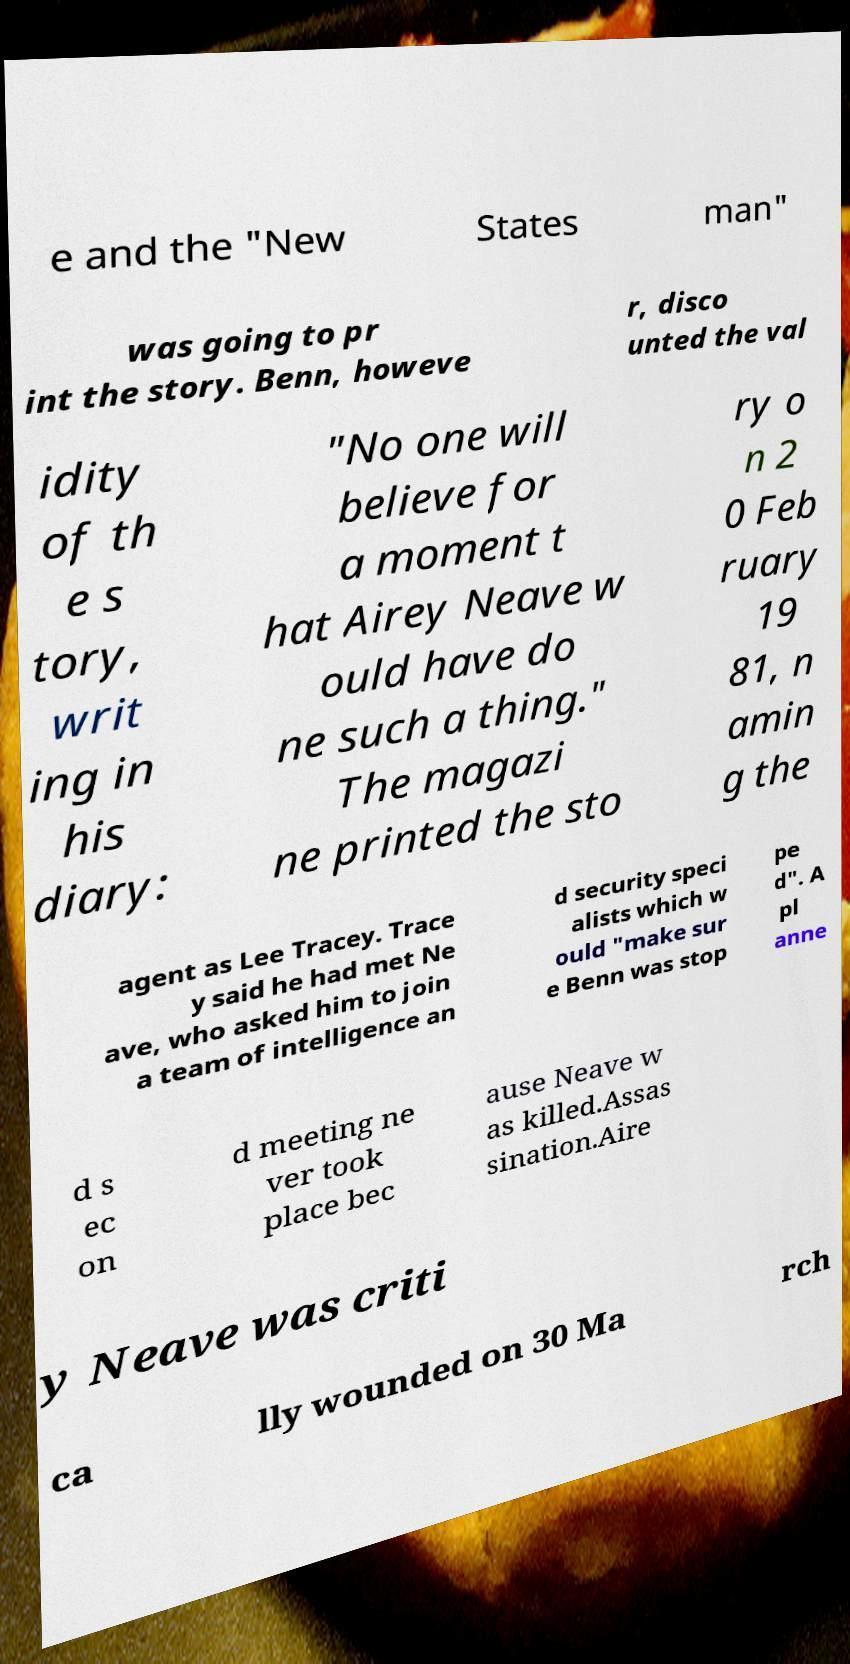Please read and relay the text visible in this image. What does it say? e and the "New States man" was going to pr int the story. Benn, howeve r, disco unted the val idity of th e s tory, writ ing in his diary: "No one will believe for a moment t hat Airey Neave w ould have do ne such a thing." The magazi ne printed the sto ry o n 2 0 Feb ruary 19 81, n amin g the agent as Lee Tracey. Trace y said he had met Ne ave, who asked him to join a team of intelligence an d security speci alists which w ould "make sur e Benn was stop pe d". A pl anne d s ec on d meeting ne ver took place bec ause Neave w as killed.Assas sination.Aire y Neave was criti ca lly wounded on 30 Ma rch 